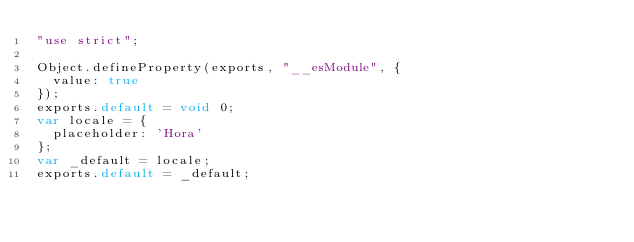<code> <loc_0><loc_0><loc_500><loc_500><_JavaScript_>"use strict";

Object.defineProperty(exports, "__esModule", {
  value: true
});
exports.default = void 0;
var locale = {
  placeholder: 'Hora'
};
var _default = locale;
exports.default = _default;</code> 